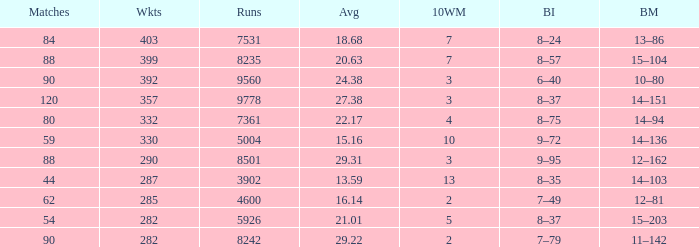What is the total number of wickets that have runs under 4600 and matches under 44? None. 